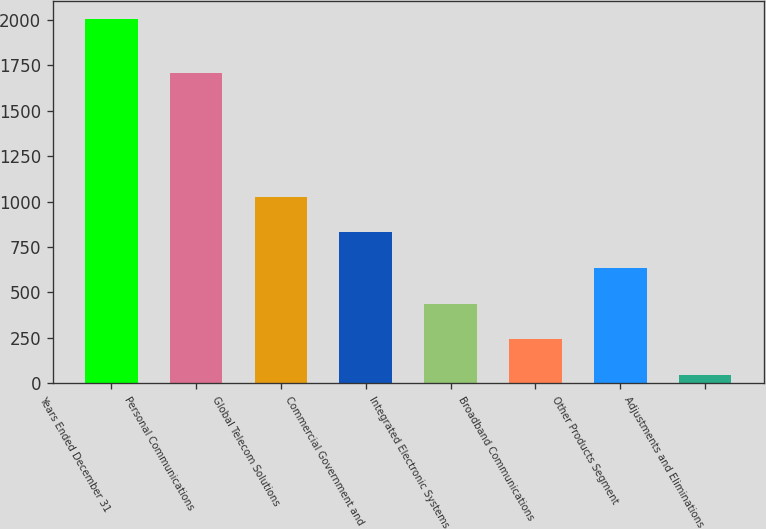Convert chart to OTSL. <chart><loc_0><loc_0><loc_500><loc_500><bar_chart><fcel>Years Ended December 31<fcel>Personal Communications<fcel>Global Telecom Solutions<fcel>Commercial Government and<fcel>Integrated Electronic Systems<fcel>Broadband Communications<fcel>Other Products Segment<fcel>Adjustments and Eliminations<nl><fcel>2004<fcel>1708<fcel>1025.5<fcel>829.8<fcel>438.4<fcel>242.7<fcel>634.1<fcel>47<nl></chart> 